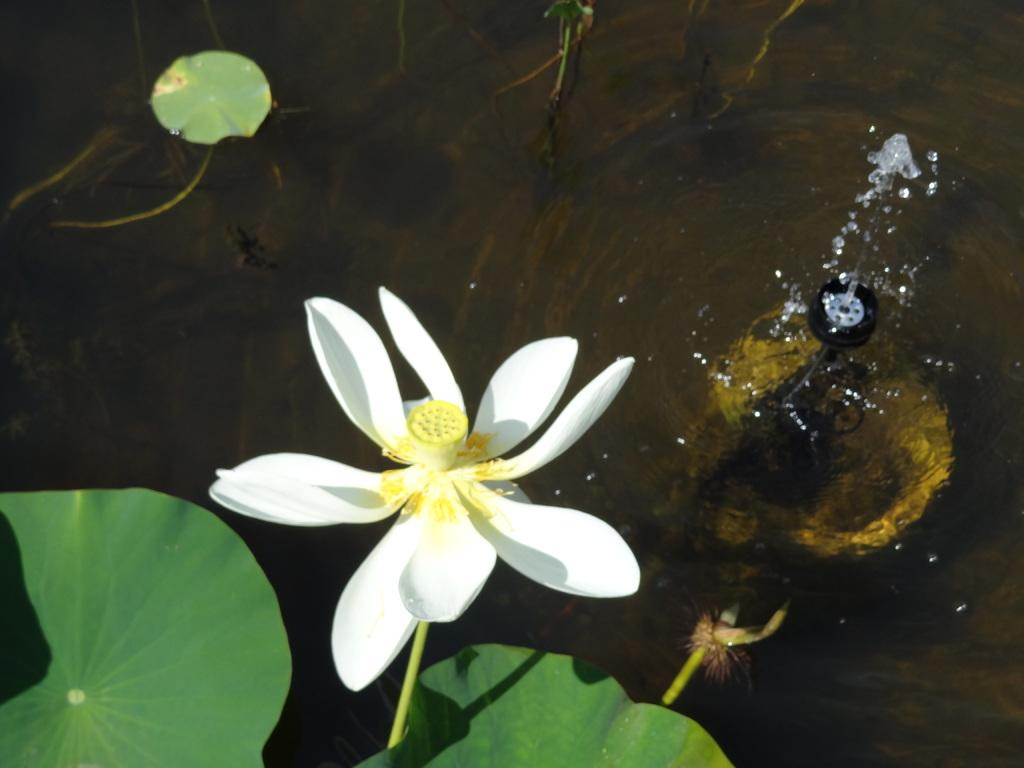What type of plant life is visible in the image? There are leaves and a flower in the image. Can you describe the setting in which the flower is located? The flower is located in or near water, as there appears to be a machine in the water in the image. What type of crime is being committed by the kittens in the image? There are no kittens present in the image, so it is not possible to determine if any crime is being committed. 